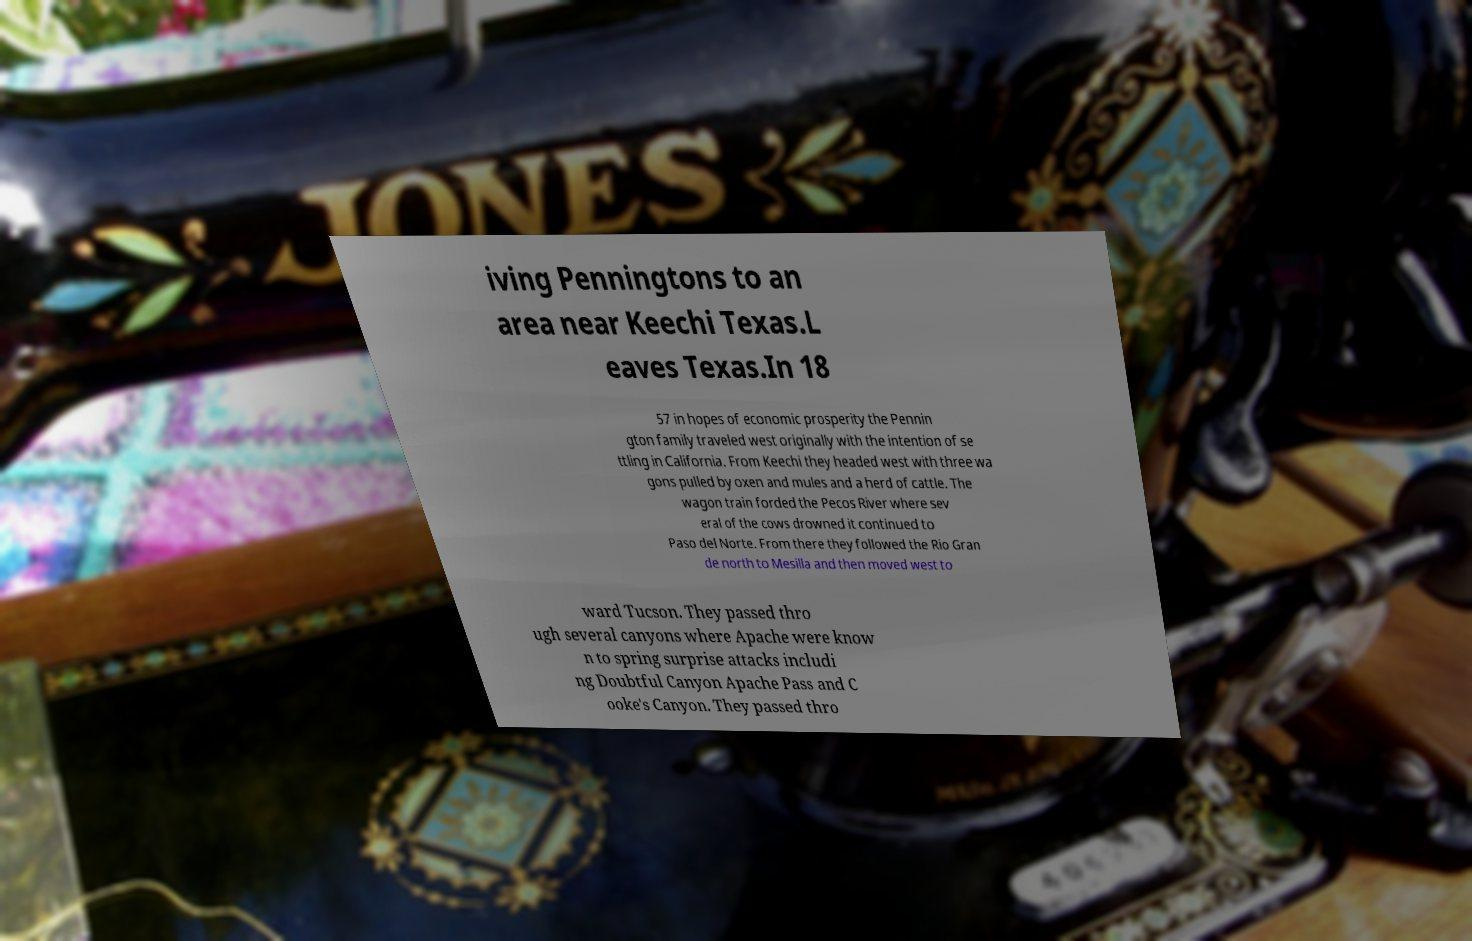I need the written content from this picture converted into text. Can you do that? iving Penningtons to an area near Keechi Texas.L eaves Texas.In 18 57 in hopes of economic prosperity the Pennin gton family traveled west originally with the intention of se ttling in California. From Keechi they headed west with three wa gons pulled by oxen and mules and a herd of cattle. The wagon train forded the Pecos River where sev eral of the cows drowned it continued to Paso del Norte. From there they followed the Rio Gran de north to Mesilla and then moved west to ward Tucson. They passed thro ugh several canyons where Apache were know n to spring surprise attacks includi ng Doubtful Canyon Apache Pass and C ooke's Canyon. They passed thro 